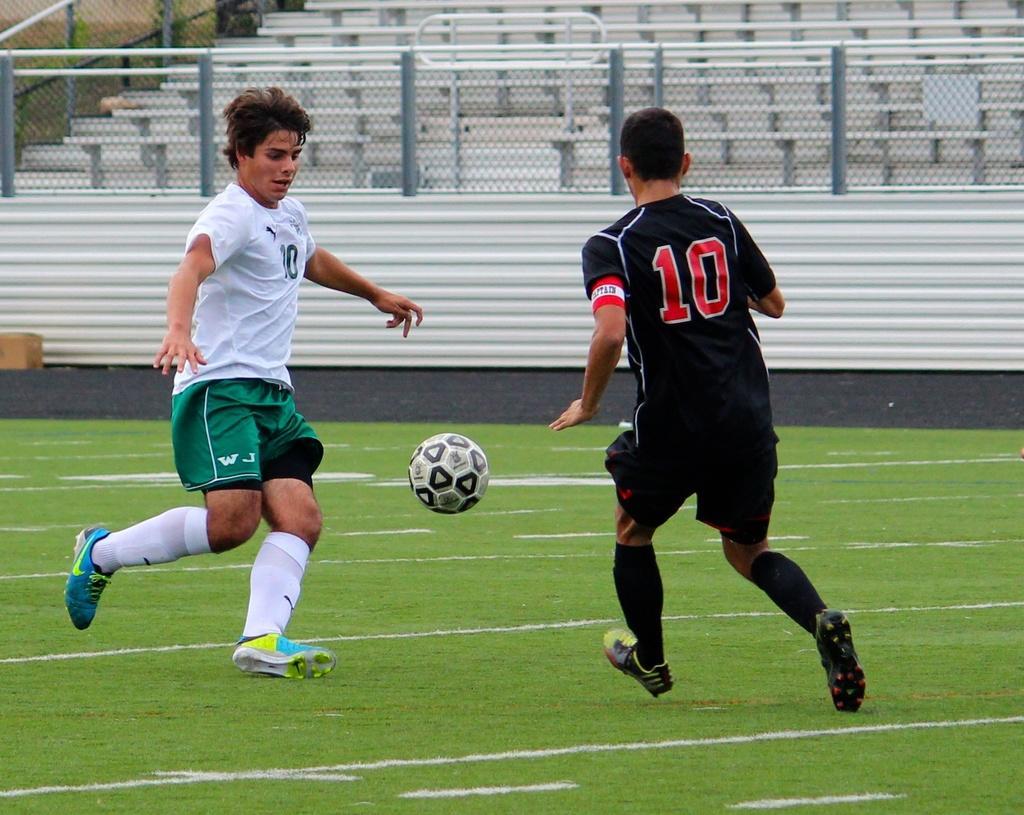Describe this image in one or two sentences. In the image in the center, we can see one ball and two persons are running. In the background we can see fences, chairs etc. 